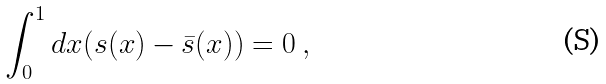<formula> <loc_0><loc_0><loc_500><loc_500>\int _ { 0 } ^ { 1 } d x ( s ( x ) - \bar { s } ( x ) ) = 0 \ ,</formula> 